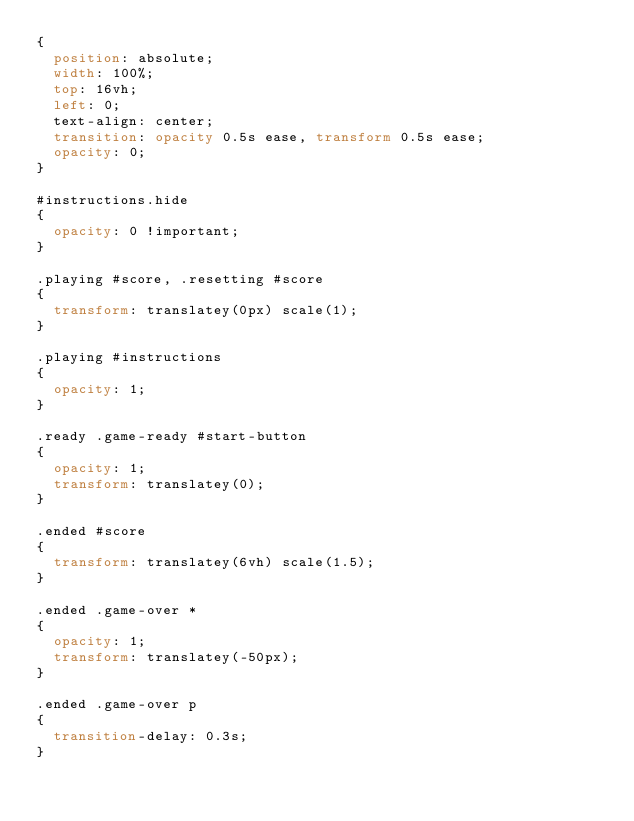<code> <loc_0><loc_0><loc_500><loc_500><_CSS_>{
	position: absolute;
	width: 100%;
	top: 16vh;
	left: 0;
	text-align: center;
	transition: opacity 0.5s ease, transform 0.5s ease;
	opacity: 0;
}

#instructions.hide
{
	opacity: 0 !important;
}

.playing #score, .resetting #score
{
	transform: translatey(0px) scale(1);
}

.playing #instructions
{
	opacity: 1;
}

.ready .game-ready #start-button
{
	opacity: 1;
	transform: translatey(0);
}

.ended #score
{
	transform: translatey(6vh) scale(1.5);
}

.ended .game-over *
{
	opacity: 1;
	transform: translatey(-50px);
}

.ended .game-over p
{
	transition-delay: 0.3s;
}</code> 